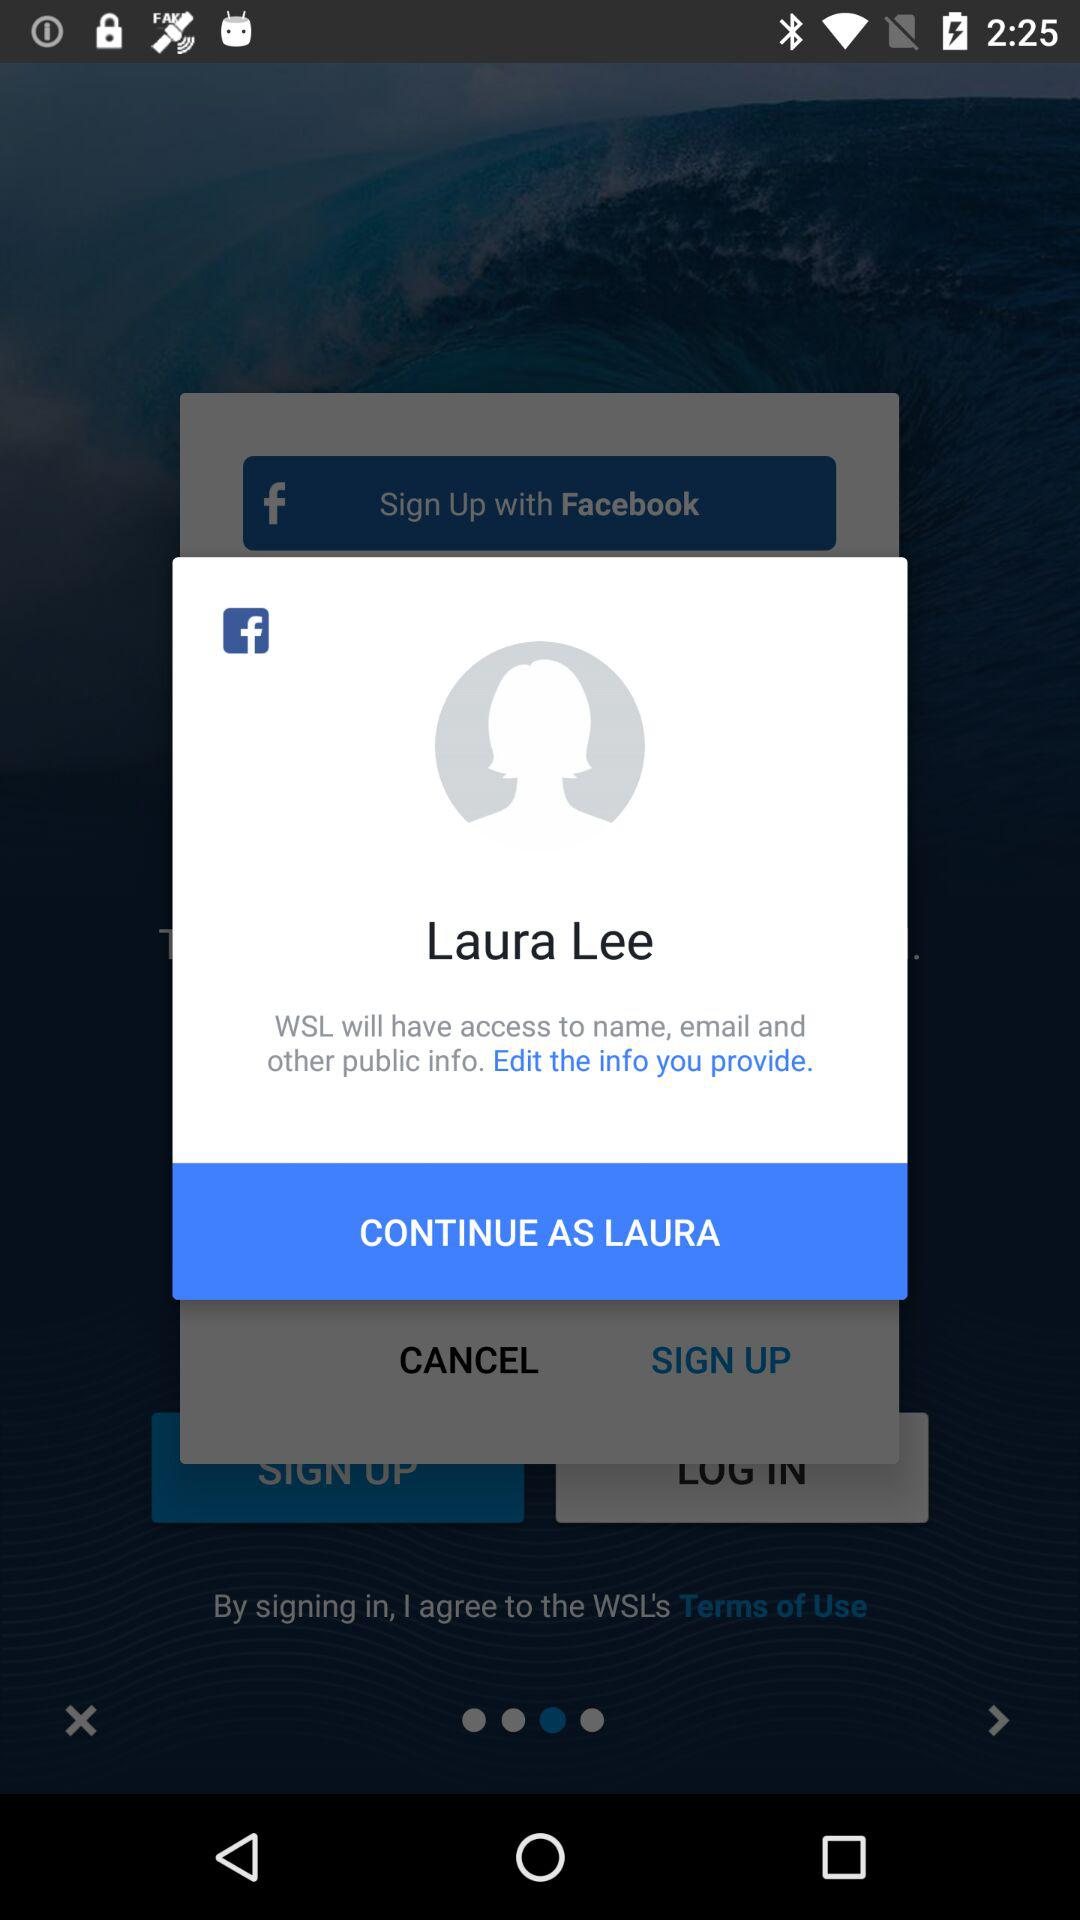Can we edit details?
When the provided information is insufficient, respond with <no answer>. <no answer> 